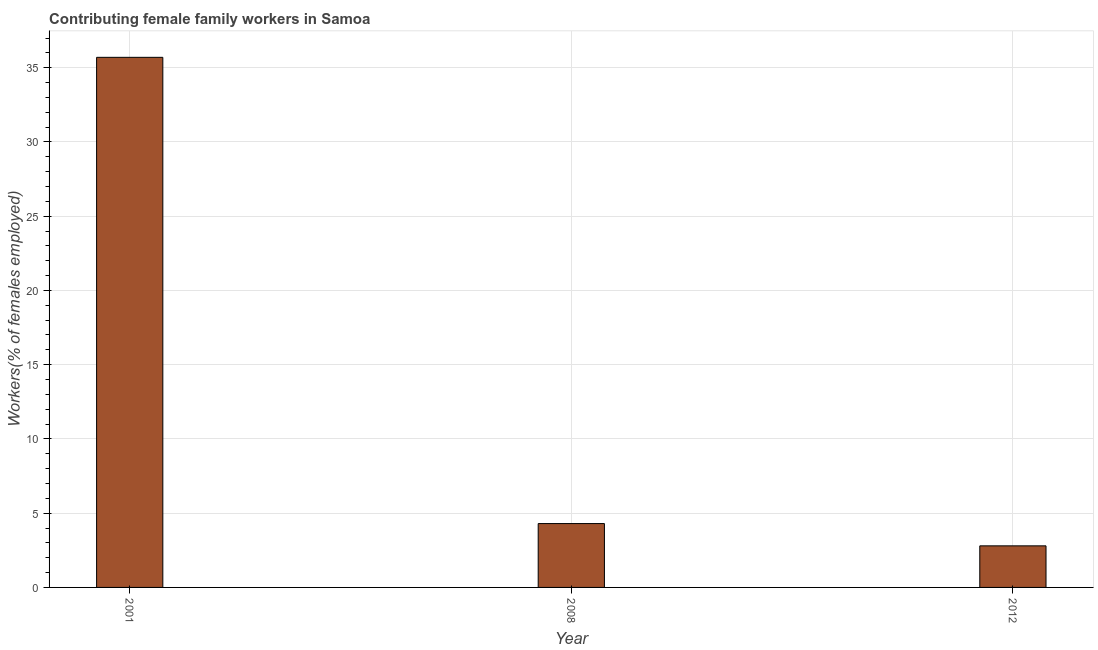Does the graph contain any zero values?
Make the answer very short. No. Does the graph contain grids?
Provide a short and direct response. Yes. What is the title of the graph?
Provide a succinct answer. Contributing female family workers in Samoa. What is the label or title of the X-axis?
Ensure brevity in your answer.  Year. What is the label or title of the Y-axis?
Offer a very short reply. Workers(% of females employed). What is the contributing female family workers in 2008?
Ensure brevity in your answer.  4.3. Across all years, what is the maximum contributing female family workers?
Make the answer very short. 35.7. Across all years, what is the minimum contributing female family workers?
Provide a short and direct response. 2.8. In which year was the contributing female family workers maximum?
Ensure brevity in your answer.  2001. What is the sum of the contributing female family workers?
Your answer should be compact. 42.8. What is the difference between the contributing female family workers in 2001 and 2012?
Provide a short and direct response. 32.9. What is the average contributing female family workers per year?
Your answer should be compact. 14.27. What is the median contributing female family workers?
Your answer should be compact. 4.3. Do a majority of the years between 2001 and 2012 (inclusive) have contributing female family workers greater than 32 %?
Offer a very short reply. No. What is the ratio of the contributing female family workers in 2008 to that in 2012?
Give a very brief answer. 1.54. Is the contributing female family workers in 2001 less than that in 2008?
Your response must be concise. No. Is the difference between the contributing female family workers in 2001 and 2008 greater than the difference between any two years?
Provide a succinct answer. No. What is the difference between the highest and the second highest contributing female family workers?
Provide a short and direct response. 31.4. Is the sum of the contributing female family workers in 2001 and 2012 greater than the maximum contributing female family workers across all years?
Your answer should be compact. Yes. What is the difference between the highest and the lowest contributing female family workers?
Your response must be concise. 32.9. In how many years, is the contributing female family workers greater than the average contributing female family workers taken over all years?
Provide a short and direct response. 1. How many bars are there?
Keep it short and to the point. 3. How many years are there in the graph?
Keep it short and to the point. 3. What is the difference between two consecutive major ticks on the Y-axis?
Your answer should be compact. 5. What is the Workers(% of females employed) in 2001?
Your response must be concise. 35.7. What is the Workers(% of females employed) in 2008?
Your answer should be compact. 4.3. What is the Workers(% of females employed) in 2012?
Your response must be concise. 2.8. What is the difference between the Workers(% of females employed) in 2001 and 2008?
Provide a short and direct response. 31.4. What is the difference between the Workers(% of females employed) in 2001 and 2012?
Offer a terse response. 32.9. What is the difference between the Workers(% of females employed) in 2008 and 2012?
Provide a succinct answer. 1.5. What is the ratio of the Workers(% of females employed) in 2001 to that in 2008?
Keep it short and to the point. 8.3. What is the ratio of the Workers(% of females employed) in 2001 to that in 2012?
Your response must be concise. 12.75. What is the ratio of the Workers(% of females employed) in 2008 to that in 2012?
Your answer should be compact. 1.54. 